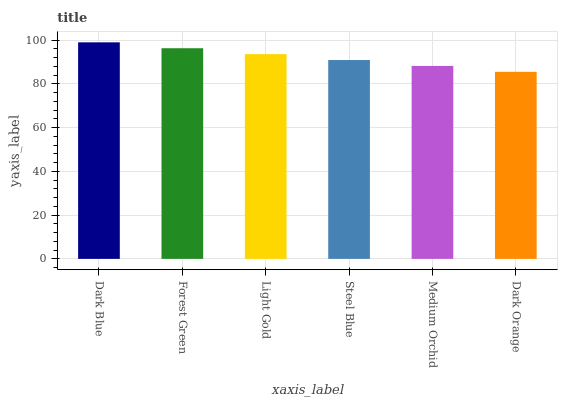Is Dark Orange the minimum?
Answer yes or no. Yes. Is Dark Blue the maximum?
Answer yes or no. Yes. Is Forest Green the minimum?
Answer yes or no. No. Is Forest Green the maximum?
Answer yes or no. No. Is Dark Blue greater than Forest Green?
Answer yes or no. Yes. Is Forest Green less than Dark Blue?
Answer yes or no. Yes. Is Forest Green greater than Dark Blue?
Answer yes or no. No. Is Dark Blue less than Forest Green?
Answer yes or no. No. Is Light Gold the high median?
Answer yes or no. Yes. Is Steel Blue the low median?
Answer yes or no. Yes. Is Medium Orchid the high median?
Answer yes or no. No. Is Dark Blue the low median?
Answer yes or no. No. 